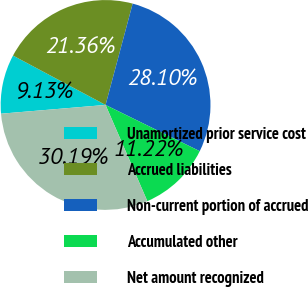Convert chart to OTSL. <chart><loc_0><loc_0><loc_500><loc_500><pie_chart><fcel>Unamortized prior service cost<fcel>Accrued liabilities<fcel>Non-current portion of accrued<fcel>Accumulated other<fcel>Net amount recognized<nl><fcel>9.13%<fcel>21.36%<fcel>28.1%<fcel>11.22%<fcel>30.19%<nl></chart> 